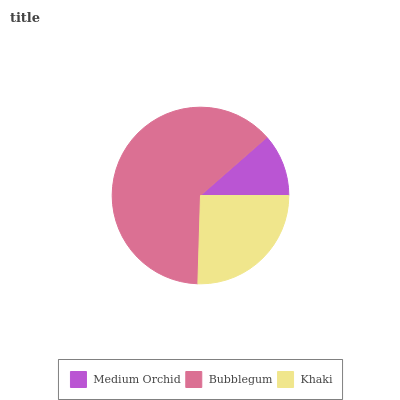Is Medium Orchid the minimum?
Answer yes or no. Yes. Is Bubblegum the maximum?
Answer yes or no. Yes. Is Khaki the minimum?
Answer yes or no. No. Is Khaki the maximum?
Answer yes or no. No. Is Bubblegum greater than Khaki?
Answer yes or no. Yes. Is Khaki less than Bubblegum?
Answer yes or no. Yes. Is Khaki greater than Bubblegum?
Answer yes or no. No. Is Bubblegum less than Khaki?
Answer yes or no. No. Is Khaki the high median?
Answer yes or no. Yes. Is Khaki the low median?
Answer yes or no. Yes. Is Bubblegum the high median?
Answer yes or no. No. Is Bubblegum the low median?
Answer yes or no. No. 